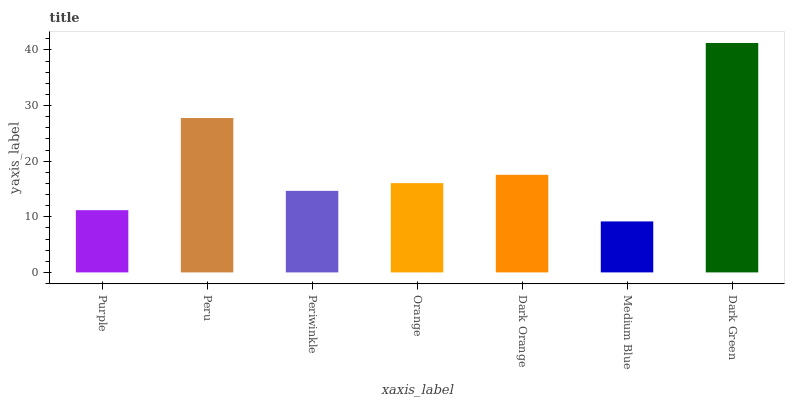Is Medium Blue the minimum?
Answer yes or no. Yes. Is Dark Green the maximum?
Answer yes or no. Yes. Is Peru the minimum?
Answer yes or no. No. Is Peru the maximum?
Answer yes or no. No. Is Peru greater than Purple?
Answer yes or no. Yes. Is Purple less than Peru?
Answer yes or no. Yes. Is Purple greater than Peru?
Answer yes or no. No. Is Peru less than Purple?
Answer yes or no. No. Is Orange the high median?
Answer yes or no. Yes. Is Orange the low median?
Answer yes or no. Yes. Is Medium Blue the high median?
Answer yes or no. No. Is Dark Green the low median?
Answer yes or no. No. 